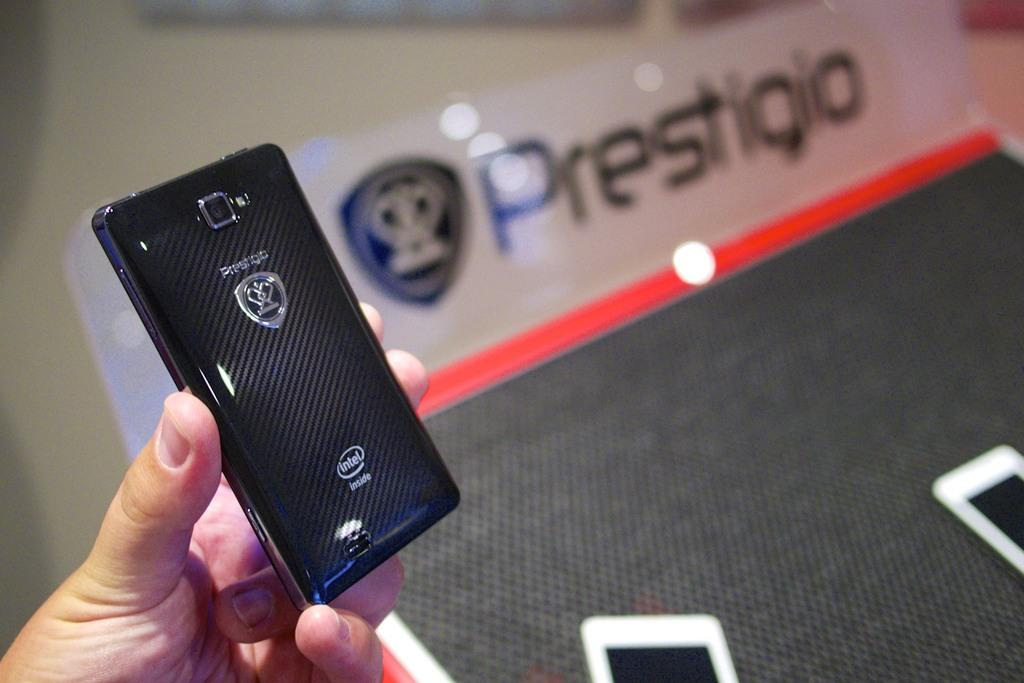<image>
Render a clear and concise summary of the photo. the name Prestigio is on the area next to the controller 